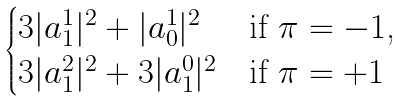Convert formula to latex. <formula><loc_0><loc_0><loc_500><loc_500>\begin{cases} 3 | a _ { 1 } ^ { 1 } | ^ { 2 } + | a _ { 0 } ^ { 1 } | ^ { 2 } & { \text {if $\pi=-1$,} } \\ 3 | a _ { 1 } ^ { 2 } | ^ { 2 } + 3 | a _ { 1 } ^ { 0 } | ^ { 2 } & { \text {if $\pi= +1$} } \end{cases}</formula> 